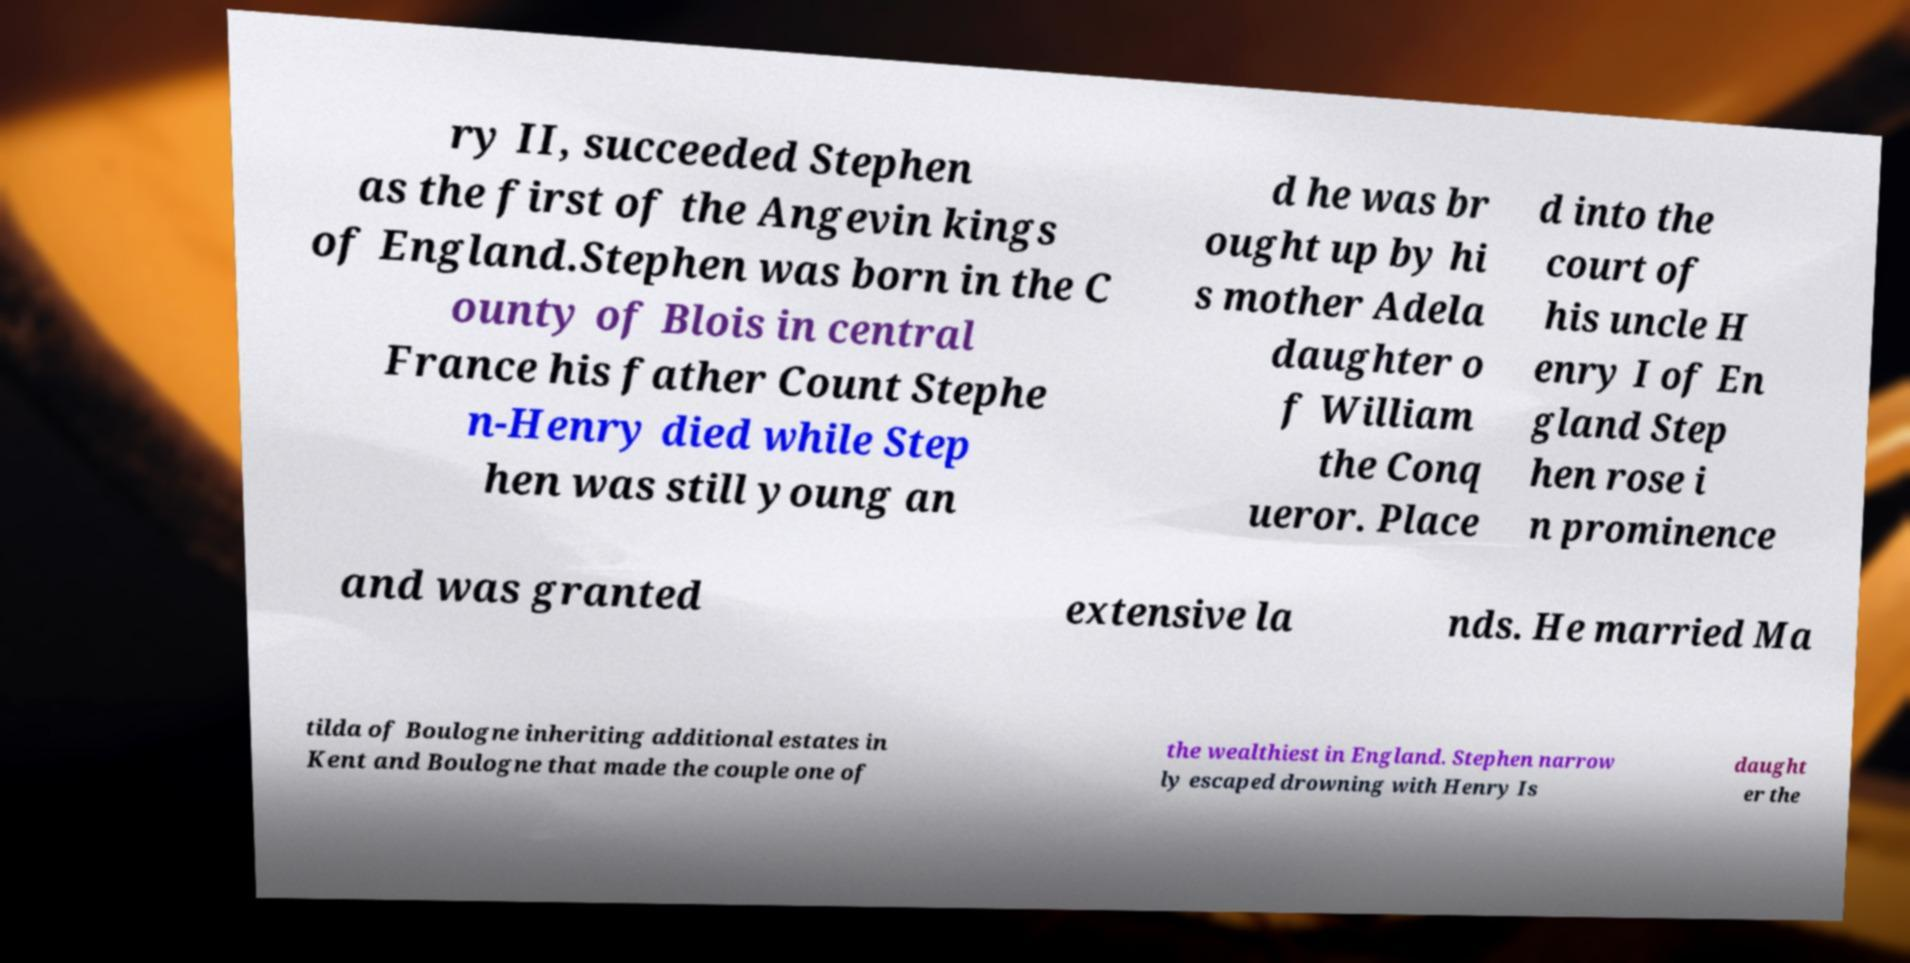Please identify and transcribe the text found in this image. ry II, succeeded Stephen as the first of the Angevin kings of England.Stephen was born in the C ounty of Blois in central France his father Count Stephe n-Henry died while Step hen was still young an d he was br ought up by hi s mother Adela daughter o f William the Conq ueror. Place d into the court of his uncle H enry I of En gland Step hen rose i n prominence and was granted extensive la nds. He married Ma tilda of Boulogne inheriting additional estates in Kent and Boulogne that made the couple one of the wealthiest in England. Stephen narrow ly escaped drowning with Henry Is daught er the 